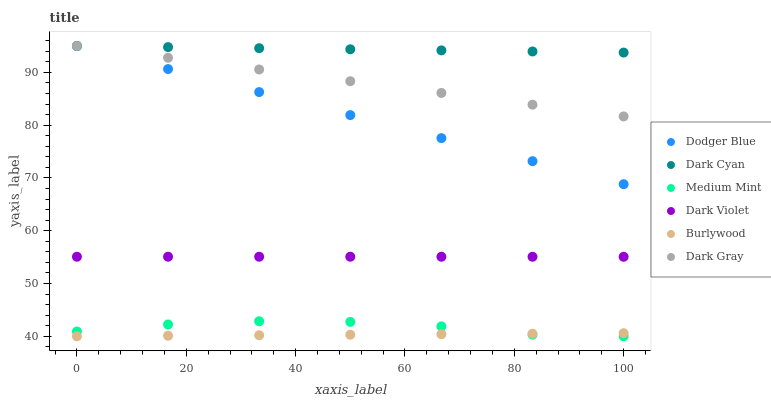Does Burlywood have the minimum area under the curve?
Answer yes or no. Yes. Does Dark Cyan have the maximum area under the curve?
Answer yes or no. Yes. Does Dark Violet have the minimum area under the curve?
Answer yes or no. No. Does Dark Violet have the maximum area under the curve?
Answer yes or no. No. Is Dark Cyan the smoothest?
Answer yes or no. Yes. Is Medium Mint the roughest?
Answer yes or no. Yes. Is Burlywood the smoothest?
Answer yes or no. No. Is Burlywood the roughest?
Answer yes or no. No. Does Medium Mint have the lowest value?
Answer yes or no. Yes. Does Dark Violet have the lowest value?
Answer yes or no. No. Does Dark Cyan have the highest value?
Answer yes or no. Yes. Does Dark Violet have the highest value?
Answer yes or no. No. Is Burlywood less than Dodger Blue?
Answer yes or no. Yes. Is Dark Cyan greater than Burlywood?
Answer yes or no. Yes. Does Burlywood intersect Medium Mint?
Answer yes or no. Yes. Is Burlywood less than Medium Mint?
Answer yes or no. No. Is Burlywood greater than Medium Mint?
Answer yes or no. No. Does Burlywood intersect Dodger Blue?
Answer yes or no. No. 